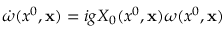<formula> <loc_0><loc_0><loc_500><loc_500>\dot { \omega } ( x ^ { 0 } , { x } ) = i g X _ { 0 } ( x ^ { 0 } , { x } ) \omega ( x ^ { 0 } , { x } )</formula> 